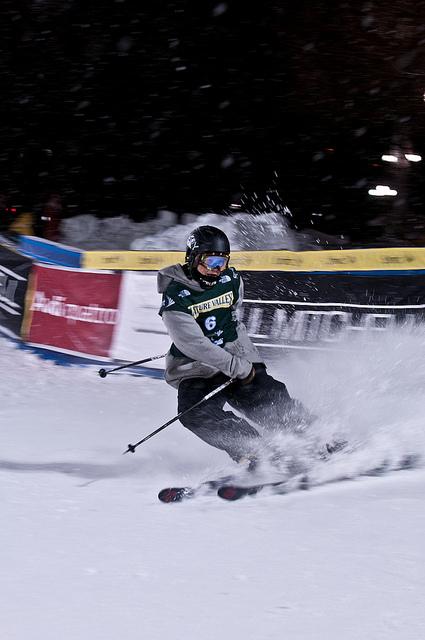What sport is this person playing?
Short answer required. Skiing. Is it day or night?
Short answer required. Night. Is he competing?
Concise answer only. Yes. 